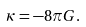<formula> <loc_0><loc_0><loc_500><loc_500>\kappa = - 8 \pi G .</formula> 